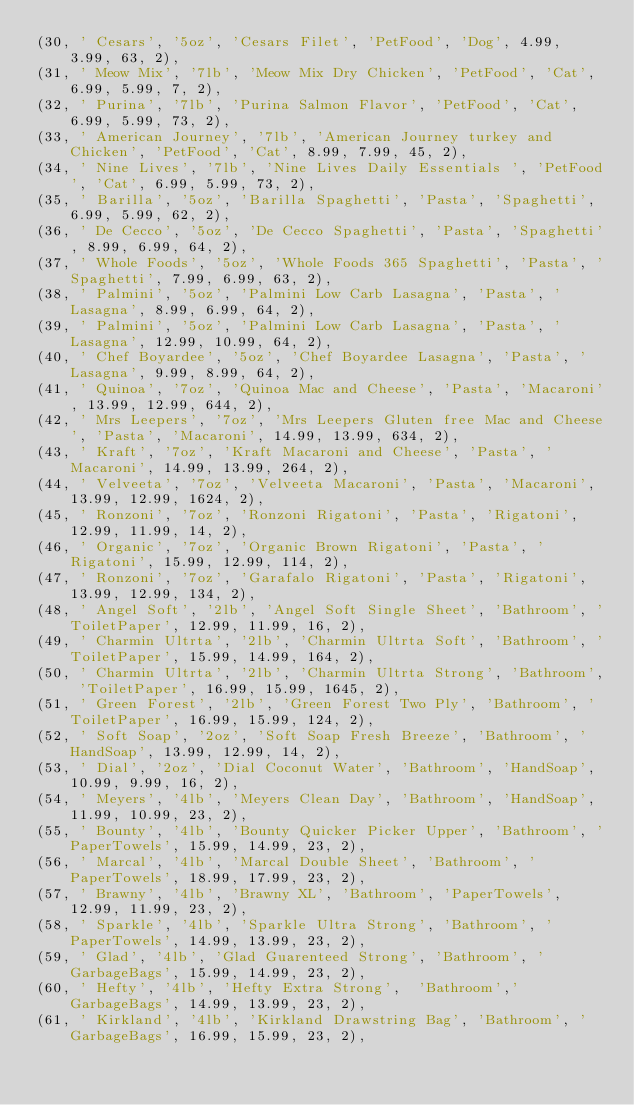<code> <loc_0><loc_0><loc_500><loc_500><_SQL_>(30, ' Cesars', '5oz', 'Cesars Filet', 'PetFood', 'Dog', 4.99, 3.99, 63, 2),
(31, ' Meow Mix', '7lb', 'Meow Mix Dry Chicken', 'PetFood', 'Cat', 6.99, 5.99, 7, 2),
(32, ' Purina', '7lb', 'Purina Salmon Flavor', 'PetFood', 'Cat', 6.99, 5.99, 73, 2),
(33, ' American Journey', '7lb', 'American Journey turkey and Chicken', 'PetFood', 'Cat', 8.99, 7.99, 45, 2),
(34, ' Nine Lives', '7lb', 'Nine Lives Daily Essentials ', 'PetFood', 'Cat', 6.99, 5.99, 73, 2),
(35, ' Barilla', '5oz', 'Barilla Spaghetti', 'Pasta', 'Spaghetti', 6.99, 5.99, 62, 2),
(36, ' De Cecco', '5oz', 'De Cecco Spaghetti', 'Pasta', 'Spaghetti', 8.99, 6.99, 64, 2),
(37, ' Whole Foods', '5oz', 'Whole Foods 365 Spaghetti', 'Pasta', 'Spaghetti', 7.99, 6.99, 63, 2),
(38, ' Palmini', '5oz', 'Palmini Low Carb Lasagna', 'Pasta', 'Lasagna', 8.99, 6.99, 64, 2),
(39, ' Palmini', '5oz', 'Palmini Low Carb Lasagna', 'Pasta', 'Lasagna', 12.99, 10.99, 64, 2),
(40, ' Chef Boyardee', '5oz', 'Chef Boyardee Lasagna', 'Pasta', 'Lasagna', 9.99, 8.99, 64, 2),
(41, ' Quinoa', '7oz', 'Quinoa Mac and Cheese', 'Pasta', 'Macaroni', 13.99, 12.99, 644, 2),
(42, ' Mrs Leepers', '7oz', 'Mrs Leepers Gluten free Mac and Cheese', 'Pasta', 'Macaroni', 14.99, 13.99, 634, 2),
(43, ' Kraft', '7oz', 'Kraft Macaroni and Cheese', 'Pasta', 'Macaroni', 14.99, 13.99, 264, 2),
(44, ' Velveeta', '7oz', 'Velveeta Macaroni', 'Pasta', 'Macaroni', 13.99, 12.99, 1624, 2),
(45, ' Ronzoni', '7oz', 'Ronzoni Rigatoni', 'Pasta', 'Rigatoni', 12.99, 11.99, 14, 2),
(46, ' Organic', '7oz', 'Organic Brown Rigatoni', 'Pasta', 'Rigatoni', 15.99, 12.99, 114, 2),
(47, ' Ronzoni', '7oz', 'Garafalo Rigatoni', 'Pasta', 'Rigatoni', 13.99, 12.99, 134, 2),
(48, ' Angel Soft', '2lb', 'Angel Soft Single Sheet', 'Bathroom', 'ToiletPaper', 12.99, 11.99, 16, 2),
(49, ' Charmin Ultrta', '2lb', 'Charmin Ultrta Soft', 'Bathroom', 'ToiletPaper', 15.99, 14.99, 164, 2),
(50, ' Charmin Ultrta', '2lb', 'Charmin Ultrta Strong', 'Bathroom', 'ToiletPaper', 16.99, 15.99, 1645, 2),
(51, ' Green Forest', '2lb', 'Green Forest Two Ply', 'Bathroom', 'ToiletPaper', 16.99, 15.99, 124, 2),
(52, ' Soft Soap', '2oz', 'Soft Soap Fresh Breeze', 'Bathroom', 'HandSoap', 13.99, 12.99, 14, 2),
(53, ' Dial', '2oz', 'Dial Coconut Water', 'Bathroom', 'HandSoap', 10.99, 9.99, 16, 2),
(54, ' Meyers', '4lb', 'Meyers Clean Day', 'Bathroom', 'HandSoap', 11.99, 10.99, 23, 2),
(55, ' Bounty', '4lb', 'Bounty Quicker Picker Upper', 'Bathroom', 'PaperTowels', 15.99, 14.99, 23, 2),
(56, ' Marcal', '4lb', 'Marcal Double Sheet', 'Bathroom', 'PaperTowels', 18.99, 17.99, 23, 2),
(57, ' Brawny', '4lb', 'Brawny XL', 'Bathroom', 'PaperTowels', 12.99, 11.99, 23, 2),
(58, ' Sparkle', '4lb', 'Sparkle Ultra Strong', 'Bathroom', 'PaperTowels', 14.99, 13.99, 23, 2),
(59, ' Glad', '4lb', 'Glad Guarenteed Strong', 'Bathroom', 'GarbageBags', 15.99, 14.99, 23, 2),
(60, ' Hefty', '4lb', 'Hefty Extra Strong',  'Bathroom','GarbageBags', 14.99, 13.99, 23, 2),
(61, ' Kirkland', '4lb', 'Kirkland Drawstring Bag', 'Bathroom', 'GarbageBags', 16.99, 15.99, 23, 2),</code> 